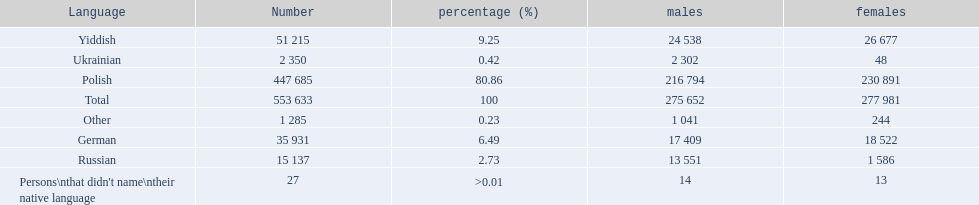What were the languages in plock governorate? Polish, Yiddish, German, Russian, Ukrainian, Other. Which language has a value of .42? Ukrainian. 